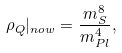Convert formula to latex. <formula><loc_0><loc_0><loc_500><loc_500>\rho _ { Q } | _ { n o w } = \frac { m _ { S } ^ { 8 } } { m _ { P l } ^ { 4 } } ,</formula> 